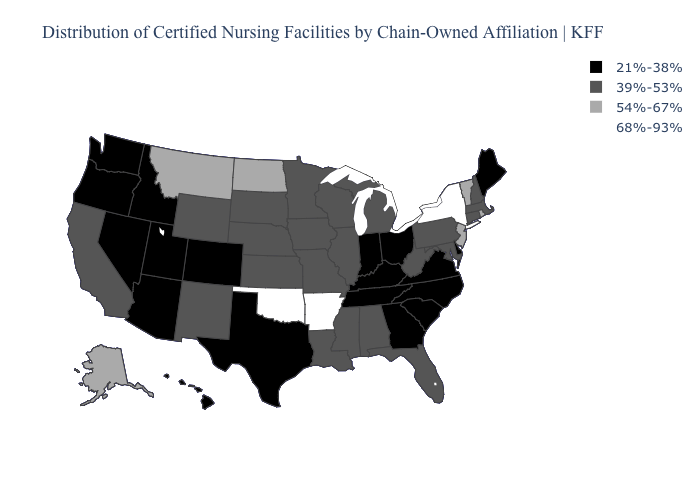Name the states that have a value in the range 68%-93%?
Be succinct. Arkansas, New York, Oklahoma. What is the value of Maine?
Keep it brief. 21%-38%. Does Iowa have the highest value in the USA?
Quick response, please. No. What is the value of Utah?
Concise answer only. 21%-38%. Among the states that border Texas , which have the highest value?
Give a very brief answer. Arkansas, Oklahoma. What is the lowest value in the USA?
Keep it brief. 21%-38%. Does Massachusetts have a lower value than Wisconsin?
Answer briefly. No. What is the value of New York?
Be succinct. 68%-93%. Does New York have the highest value in the USA?
Give a very brief answer. Yes. Does Rhode Island have the highest value in the Northeast?
Keep it brief. No. What is the value of Georgia?
Answer briefly. 21%-38%. What is the value of Washington?
Write a very short answer. 21%-38%. What is the lowest value in the South?
Quick response, please. 21%-38%. How many symbols are there in the legend?
Give a very brief answer. 4. Does the first symbol in the legend represent the smallest category?
Short answer required. Yes. 